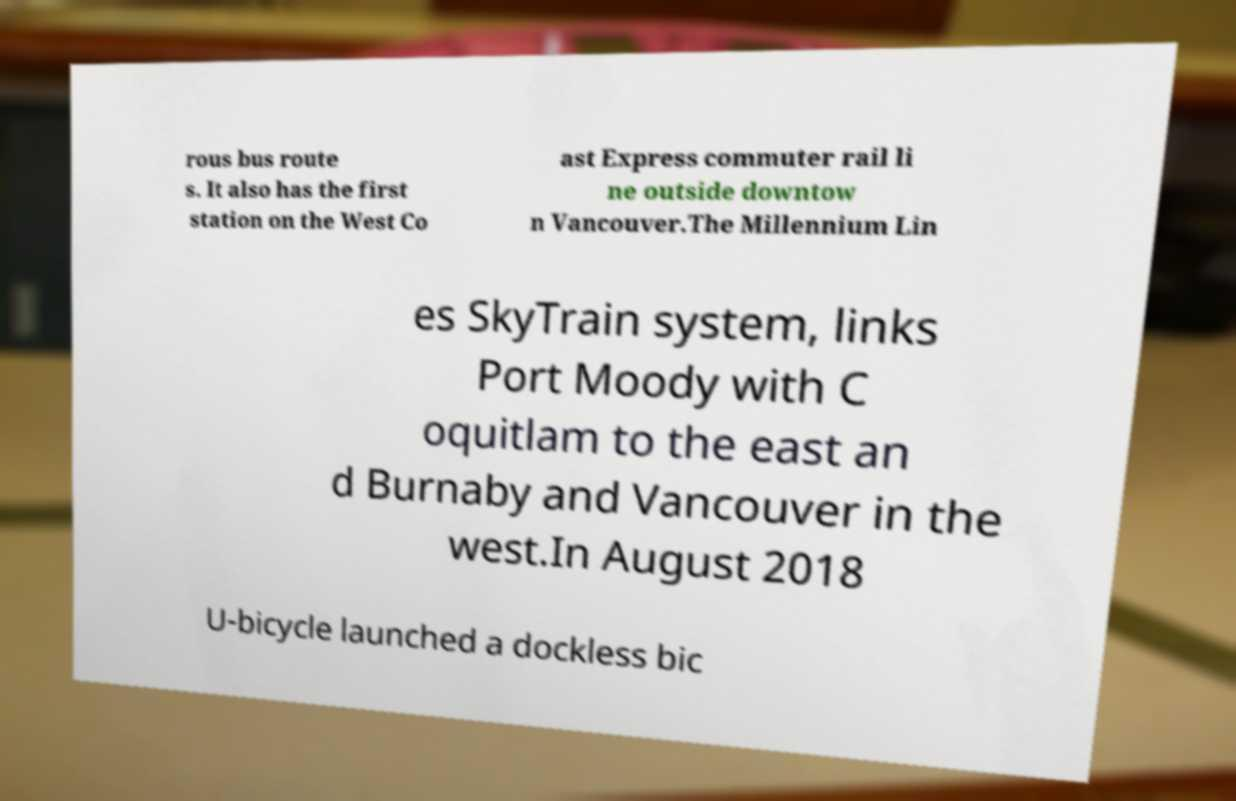Can you read and provide the text displayed in the image?This photo seems to have some interesting text. Can you extract and type it out for me? rous bus route s. It also has the first station on the West Co ast Express commuter rail li ne outside downtow n Vancouver.The Millennium Lin es SkyTrain system, links Port Moody with C oquitlam to the east an d Burnaby and Vancouver in the west.In August 2018 U-bicycle launched a dockless bic 